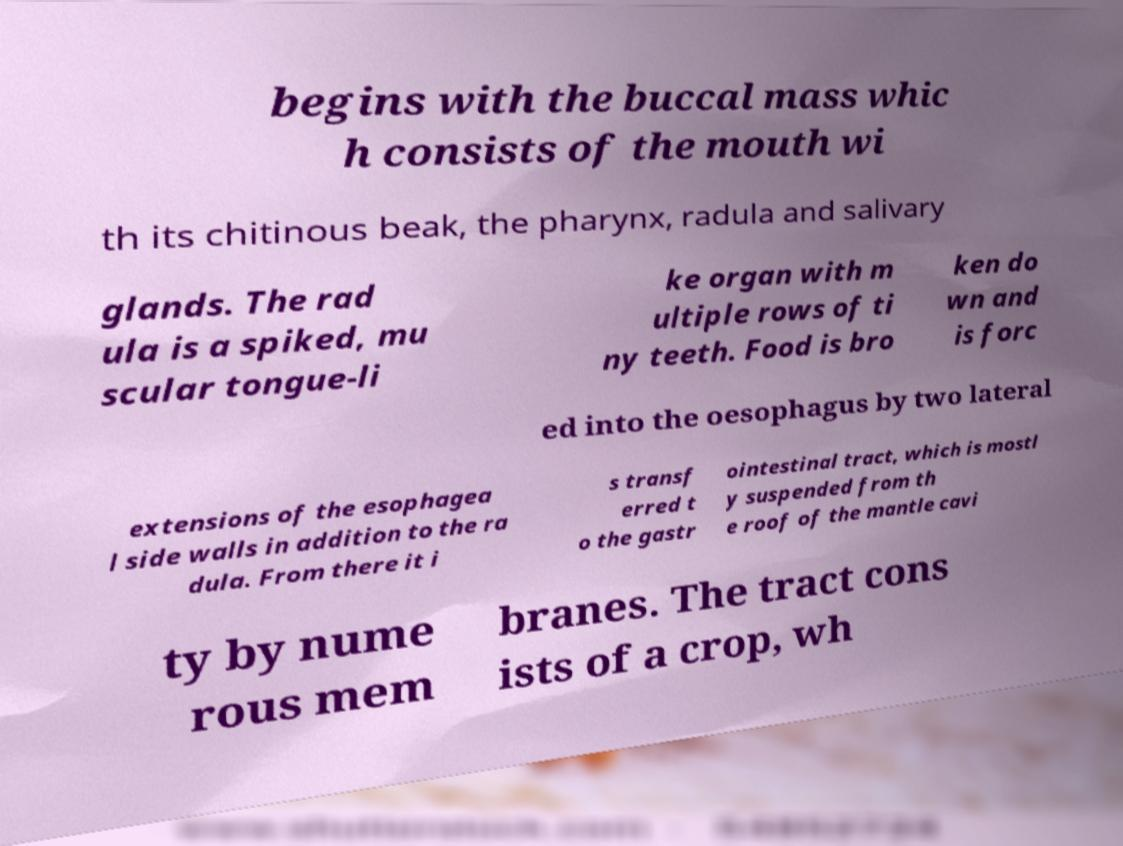For documentation purposes, I need the text within this image transcribed. Could you provide that? begins with the buccal mass whic h consists of the mouth wi th its chitinous beak, the pharynx, radula and salivary glands. The rad ula is a spiked, mu scular tongue-li ke organ with m ultiple rows of ti ny teeth. Food is bro ken do wn and is forc ed into the oesophagus by two lateral extensions of the esophagea l side walls in addition to the ra dula. From there it i s transf erred t o the gastr ointestinal tract, which is mostl y suspended from th e roof of the mantle cavi ty by nume rous mem branes. The tract cons ists of a crop, wh 